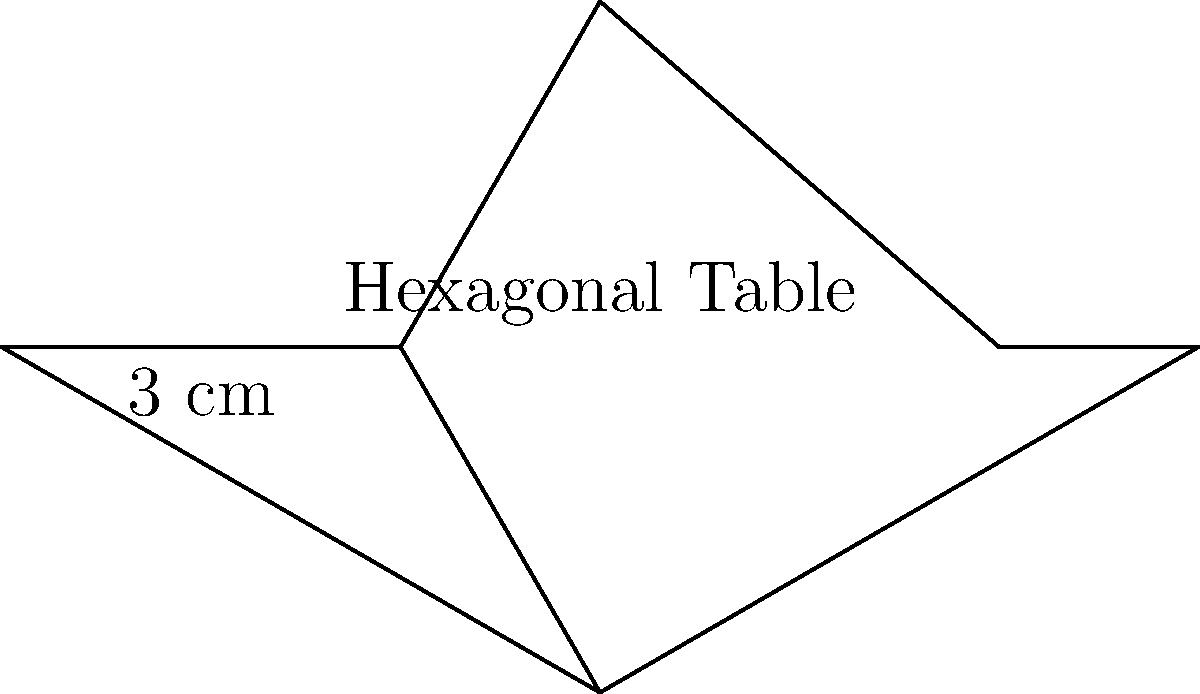A startup is planning to purchase a hexagonal conference table for their new office space. The table has a regular hexagonal shape with each side measuring 3 cm. As a talent acquisition specialist, you need to determine the table's perimeter to ensure it fits in the designated area. Calculate the perimeter of the hexagonal conference table. To calculate the perimeter of a regular hexagon, we need to follow these steps:

1. Identify the length of one side: In this case, each side is 3 cm.

2. Recall that a hexagon has 6 equal sides.

3. Use the formula for the perimeter of a regular polygon:
   Perimeter = number of sides × length of one side

4. Plug in the values:
   Perimeter = 6 × 3 cm

5. Perform the calculation:
   Perimeter = 18 cm

Therefore, the perimeter of the hexagonal conference table is 18 cm.
Answer: 18 cm 